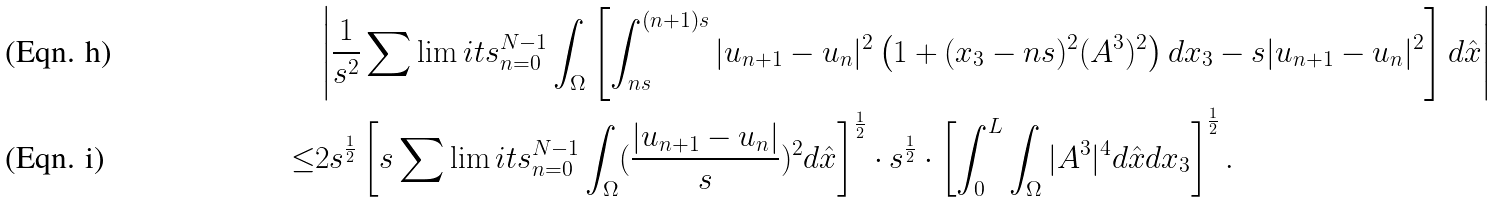Convert formula to latex. <formula><loc_0><loc_0><loc_500><loc_500>& \left | \frac { 1 } { s ^ { 2 } } \sum \lim i t s _ { n = 0 } ^ { N - 1 } \int _ { \Omega } \left [ \int _ { n s } ^ { ( n + 1 ) s } | u _ { n + 1 } - u _ { n } | ^ { 2 } \left ( 1 + ( x _ { 3 } - n s ) ^ { 2 } ( A ^ { 3 } ) ^ { 2 } \right ) d x _ { 3 } - s | u _ { n + 1 } - u _ { n } | ^ { 2 } \right ] d \hat { x } \right | \\ \leq & 2 s ^ { \frac { 1 } { 2 } } \left [ s \sum \lim i t s _ { n = 0 } ^ { N - 1 } \int _ { \Omega } ( \frac { | u _ { n + 1 } - u _ { n } | } { s } ) ^ { 2 } d \hat { x } \right ] ^ { \frac { 1 } { 2 } } \cdot s ^ { \frac { 1 } { 2 } } \cdot \left [ \int _ { 0 } ^ { L } \int _ { \Omega } | A ^ { 3 } | ^ { 4 } d \hat { x } d x _ { 3 } \right ] ^ { \frac { 1 } { 2 } } .</formula> 